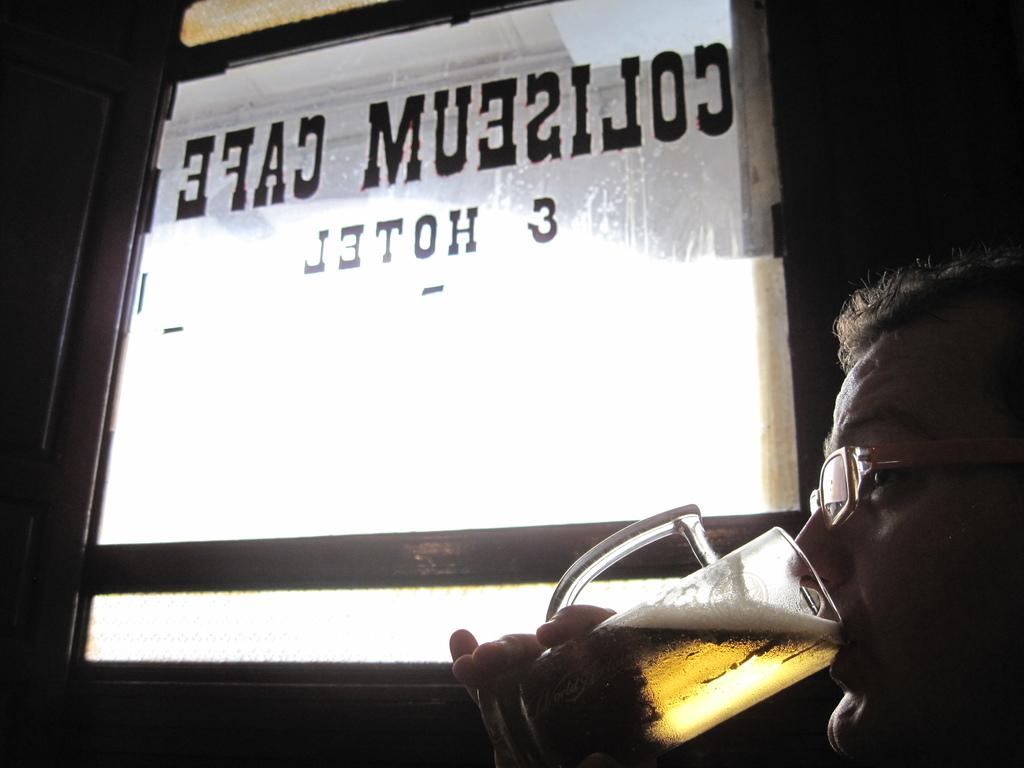What is the man in the image doing? The man is drinking from a glass. How is the man holding the glass? The glass is held in the man's hand. What can be seen in the background of the image? There is a glass door in the background of the image. What is written on the glass door? There is text written on the glass door. What type of pancake can be seen on the man's plate in the image? There is no plate or pancake visible in the image; the man is drinking from a glass. What type of loaf is the man holding in the image? There is no loaf present in the image; the man is holding a glass. 